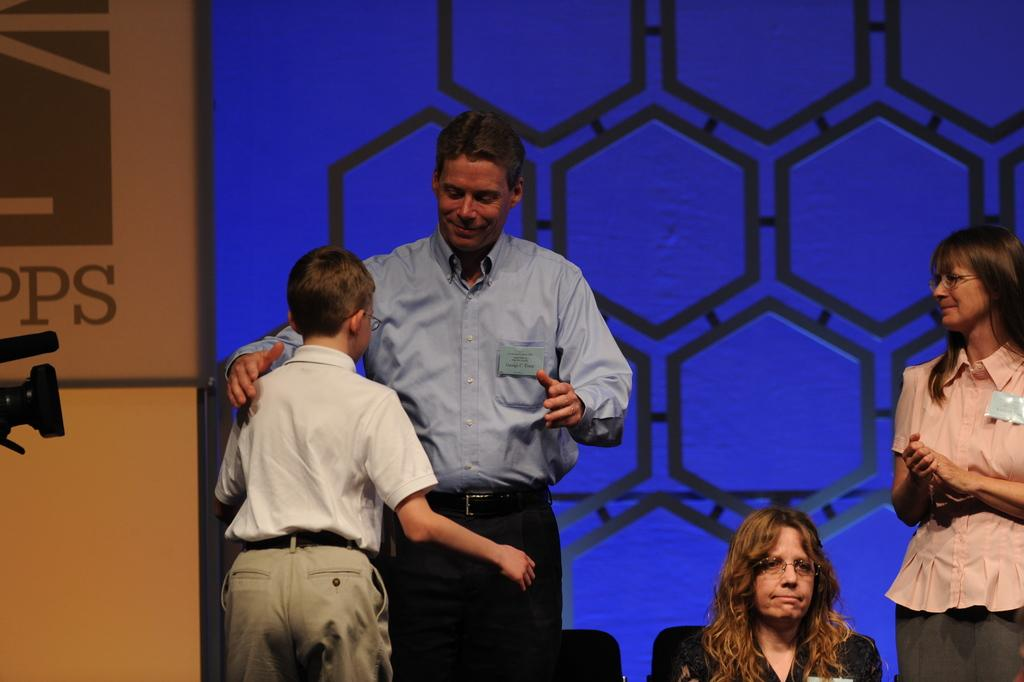Where is the woman located in the image? The woman is sitting in the bottom left corner of the image. What are the people in the image doing? The people in the image are standing and smiling. What can be seen behind the people in the image? There is a wall visible behind the people. What object is present on the left side of the image? There is a camera on the left side of the image. How many apples are being held by the maid in the image? There is no maid present in the image, and therefore no apples can be held by a maid. 